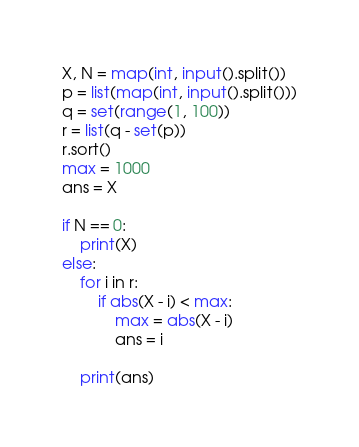<code> <loc_0><loc_0><loc_500><loc_500><_Python_>X, N = map(int, input().split())
p = list(map(int, input().split()))
q = set(range(1, 100))
r = list(q - set(p))
r.sort()
max = 1000
ans = X

if N == 0:
    print(X)
else:
    for i in r:
        if abs(X - i) < max:
            max = abs(X - i)
            ans = i

    print(ans)</code> 